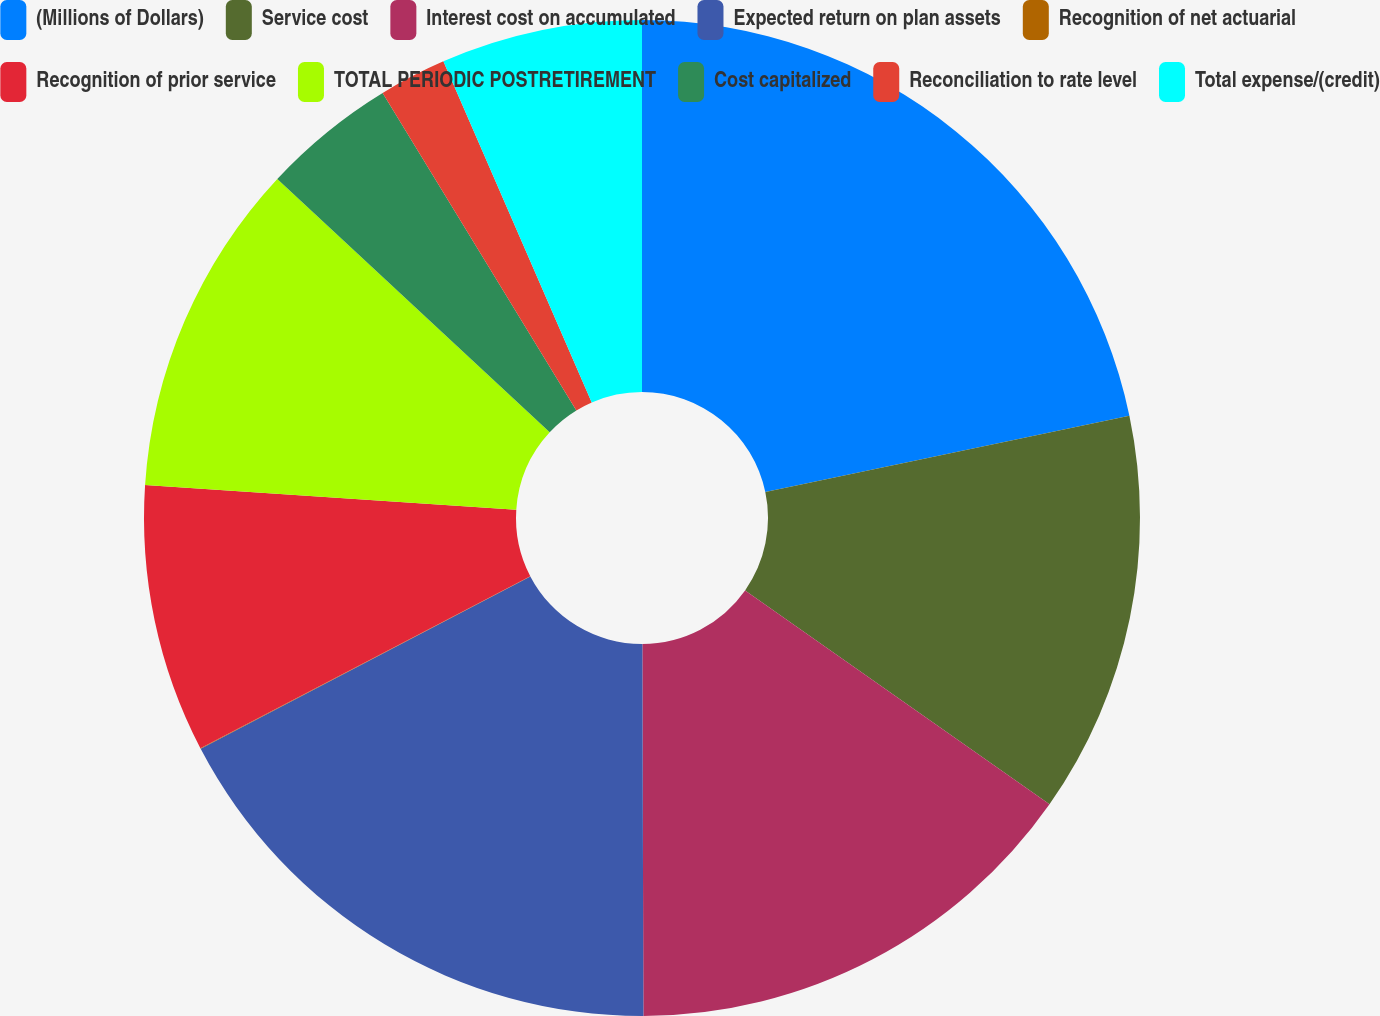<chart> <loc_0><loc_0><loc_500><loc_500><pie_chart><fcel>(Millions of Dollars)<fcel>Service cost<fcel>Interest cost on accumulated<fcel>Expected return on plan assets<fcel>Recognition of net actuarial<fcel>Recognition of prior service<fcel>TOTAL PERIODIC POSTRETIREMENT<fcel>Cost capitalized<fcel>Reconciliation to rate level<fcel>Total expense/(credit)<nl><fcel>21.71%<fcel>13.04%<fcel>15.21%<fcel>17.38%<fcel>0.02%<fcel>8.7%<fcel>10.87%<fcel>4.36%<fcel>2.19%<fcel>6.53%<nl></chart> 